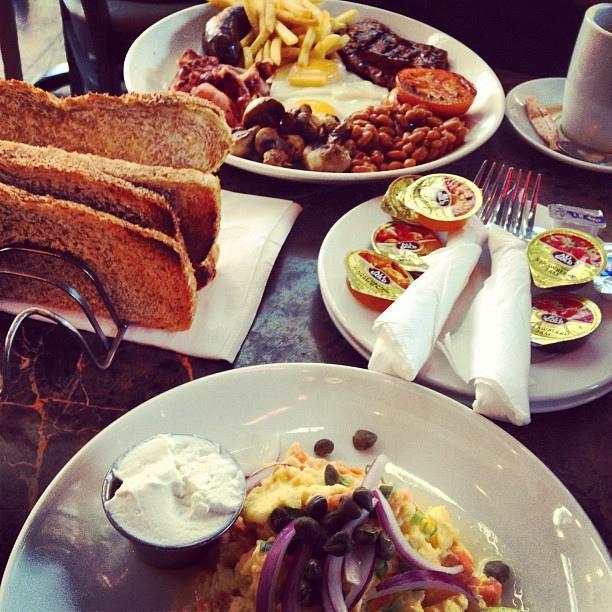What is on the plate with the two wrapped forks?
Choose the correct response, then elucidate: 'Answer: answer
Rationale: rationale.'
Options: Butter jelly, mayonnaise, ketchup, mustard. Answer: butter jelly.
Rationale: Because its near wheel the bread is located and packaged as butter. 